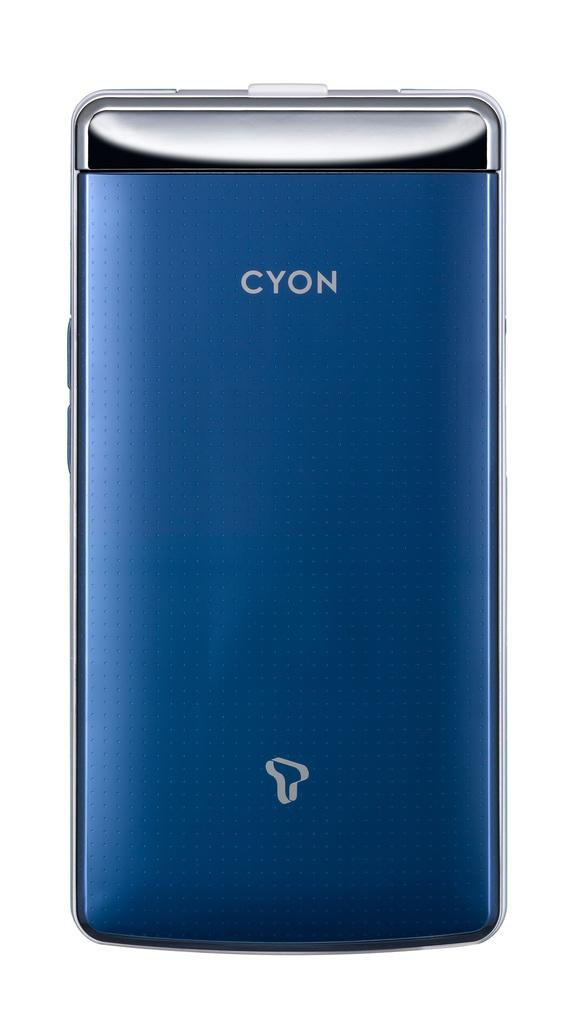<image>
Present a compact description of the photo's key features. A cellphone from Cyon with a blue and silver casing. 